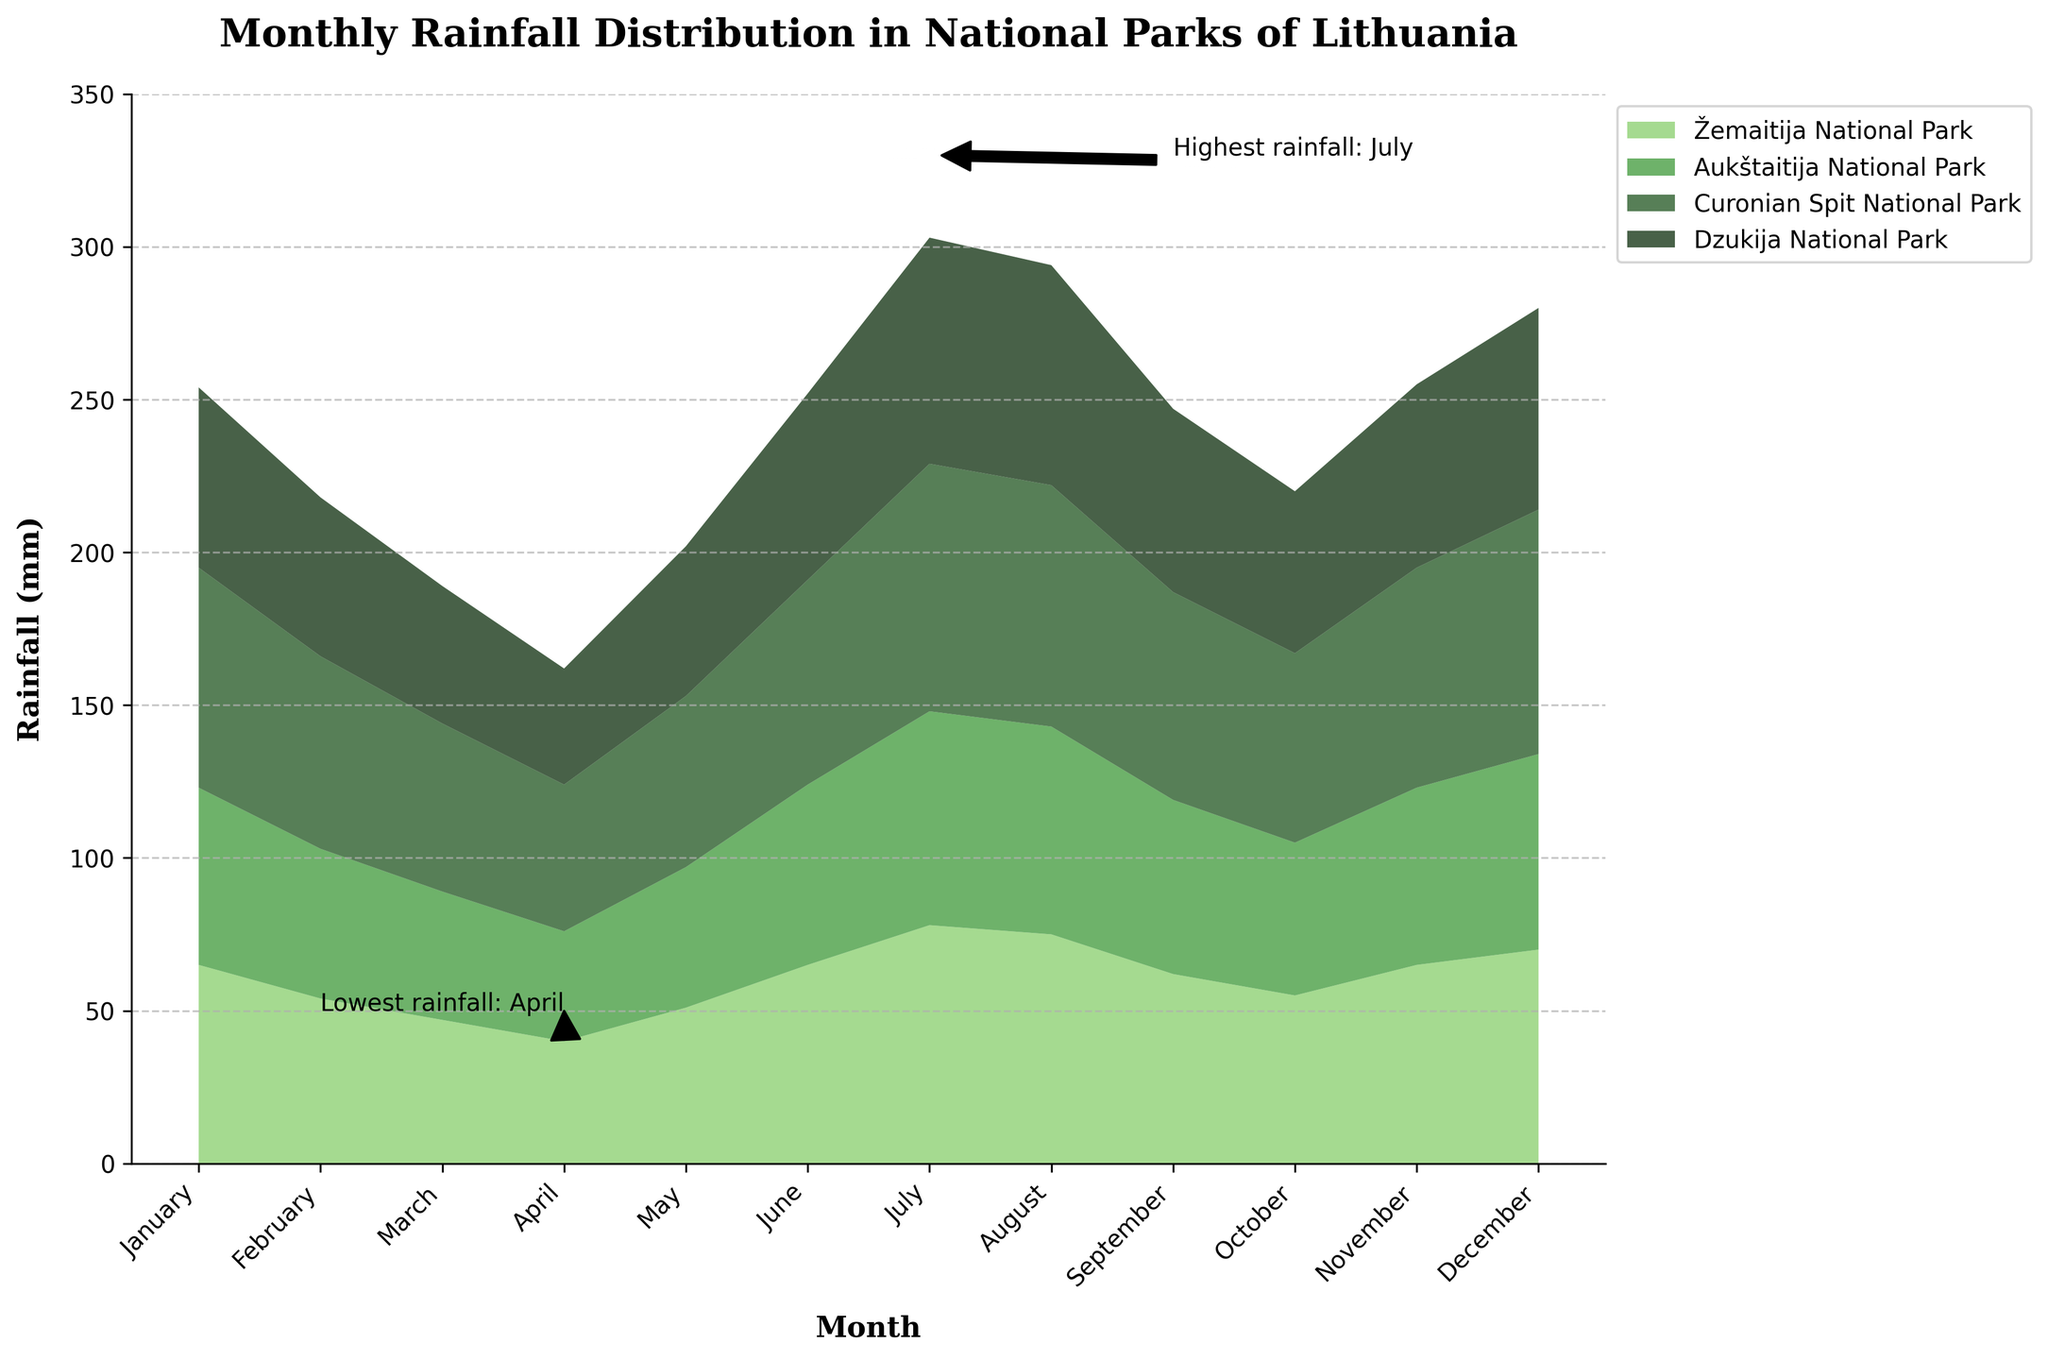What is the title of the chart? The title of the chart is usually displayed at the top. In this case, it reads 'Monthly Rainfall Distribution in National Parks of Lithuania'.
Answer: 'Monthly Rainfall Distribution in National Parks of Lithuania' Which month has the highest total rainfall? Identify the month with the highest point in the stacked area chart. In this case, annotations highlight July as having the highest total rainfall.
Answer: July Which month has the lowest total rainfall? Identify the month with the lowest point in the stacked area chart. Annotations on the figure highlight April as having the lowest total rainfall.
Answer: April How many national parks are represented in the chart? Count the number of different colors in the stacked area chart or check the legend entries. There are four different colors, each representing a national park: Žemaitija, Aukštaitija, Curonian Spit, and Dzukija National Parks.
Answer: 4 In which month does the Dzukija National Park have the highest rainfall? Look for the highest value of the area color representing Dzukija National Park (dark green) in the chart. July has the highest rainfall for Dzukija at 74mm.
Answer: July Compare the rainfall in January and July for the Curonian Spit National Park. Which month has more rainfall? Check the height of the stacked area in January and July for the Curonian Spit National Park (represented by a light green area). July has higher rainfall (81mm) compared to January (72mm).
Answer: July What's the total rainfall in June for Žemaitija and Dzukija National Parks? Find the heights for Žemaitija (65mm) and Dzukija (61mm) in June, then sum these values: 65 + 61 = 126mm.
Answer: 126mm Which park has the most rainfall in February? Compare the heights of each color segment for February. Curonian Spit National Park has the most rainfall with 63mm.
Answer: Curonian Spit National Park How does the rainfall in November in Žemaitija National Park compare to October? Check the values for November (65mm) and October (55mm) for Žemaitija National Park. November has more rainfall than October by 10mm.
Answer: November What is the overall trend of rainfall from January to December in Aukštaitija National Park? Analyze the heights of the area represented by Aukštaitija across months. Rainfall peaks in July and decreases in December, indicating an upward trend to July, then downward.
Answer: Peaks in July, decreases thereafter 